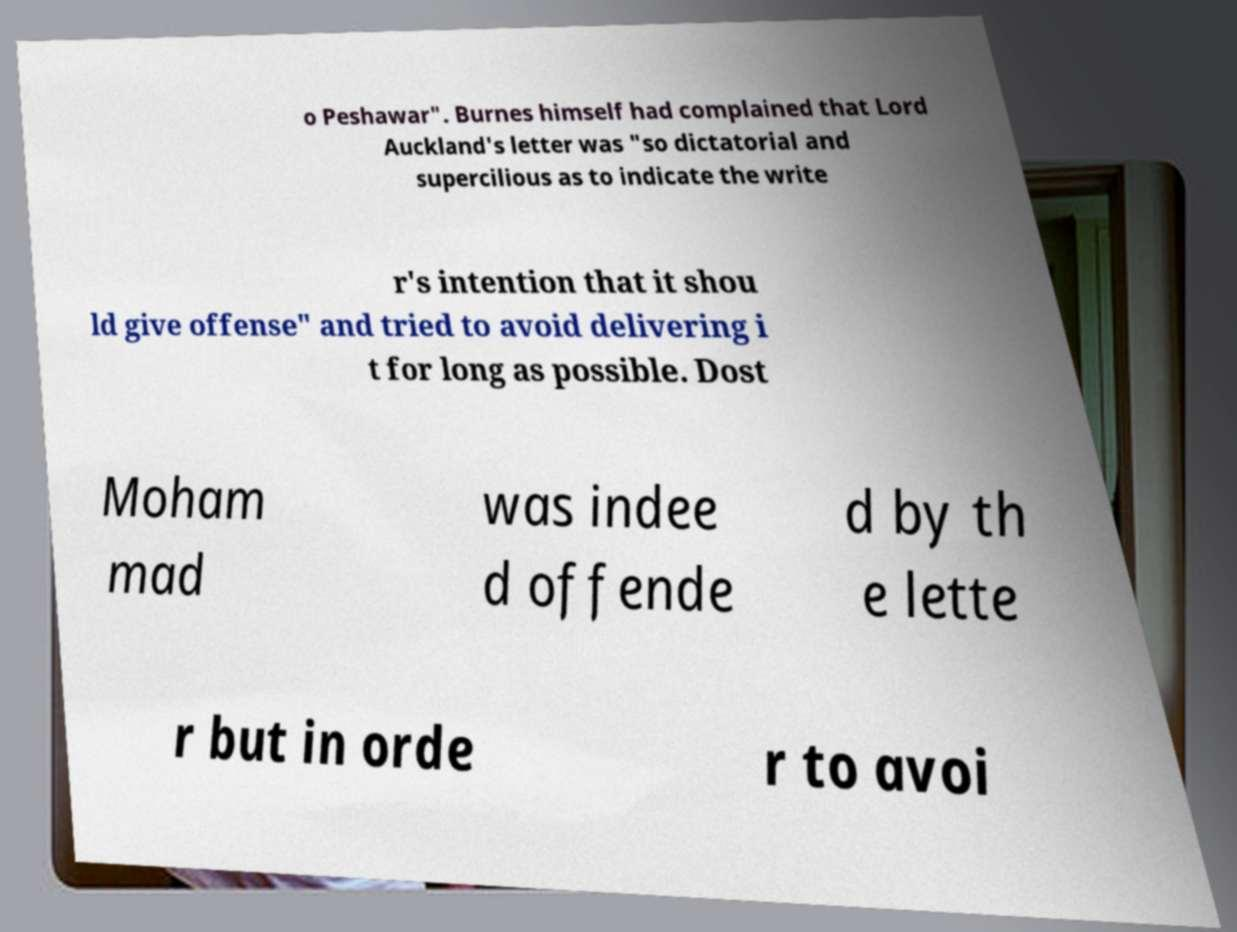Could you assist in decoding the text presented in this image and type it out clearly? o Peshawar". Burnes himself had complained that Lord Auckland's letter was "so dictatorial and supercilious as to indicate the write r's intention that it shou ld give offense" and tried to avoid delivering i t for long as possible. Dost Moham mad was indee d offende d by th e lette r but in orde r to avoi 